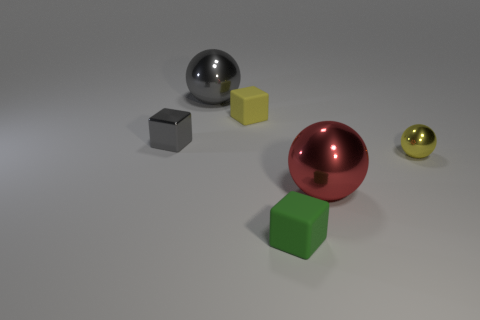Subtract all large balls. How many balls are left? 1 Add 4 tiny yellow objects. How many objects exist? 10 Subtract all red cubes. Subtract all gray balls. How many cubes are left? 3 Subtract all cyan balls. How many red cubes are left? 0 Subtract all tiny brown shiny cubes. Subtract all small rubber things. How many objects are left? 4 Add 6 metal cubes. How many metal cubes are left? 7 Add 2 big metallic things. How many big metallic things exist? 4 Subtract 0 purple blocks. How many objects are left? 6 Subtract 3 blocks. How many blocks are left? 0 